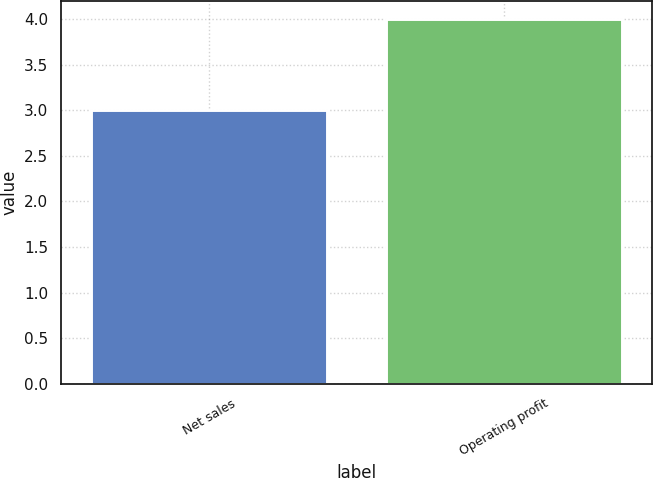<chart> <loc_0><loc_0><loc_500><loc_500><bar_chart><fcel>Net sales<fcel>Operating profit<nl><fcel>3<fcel>4<nl></chart> 